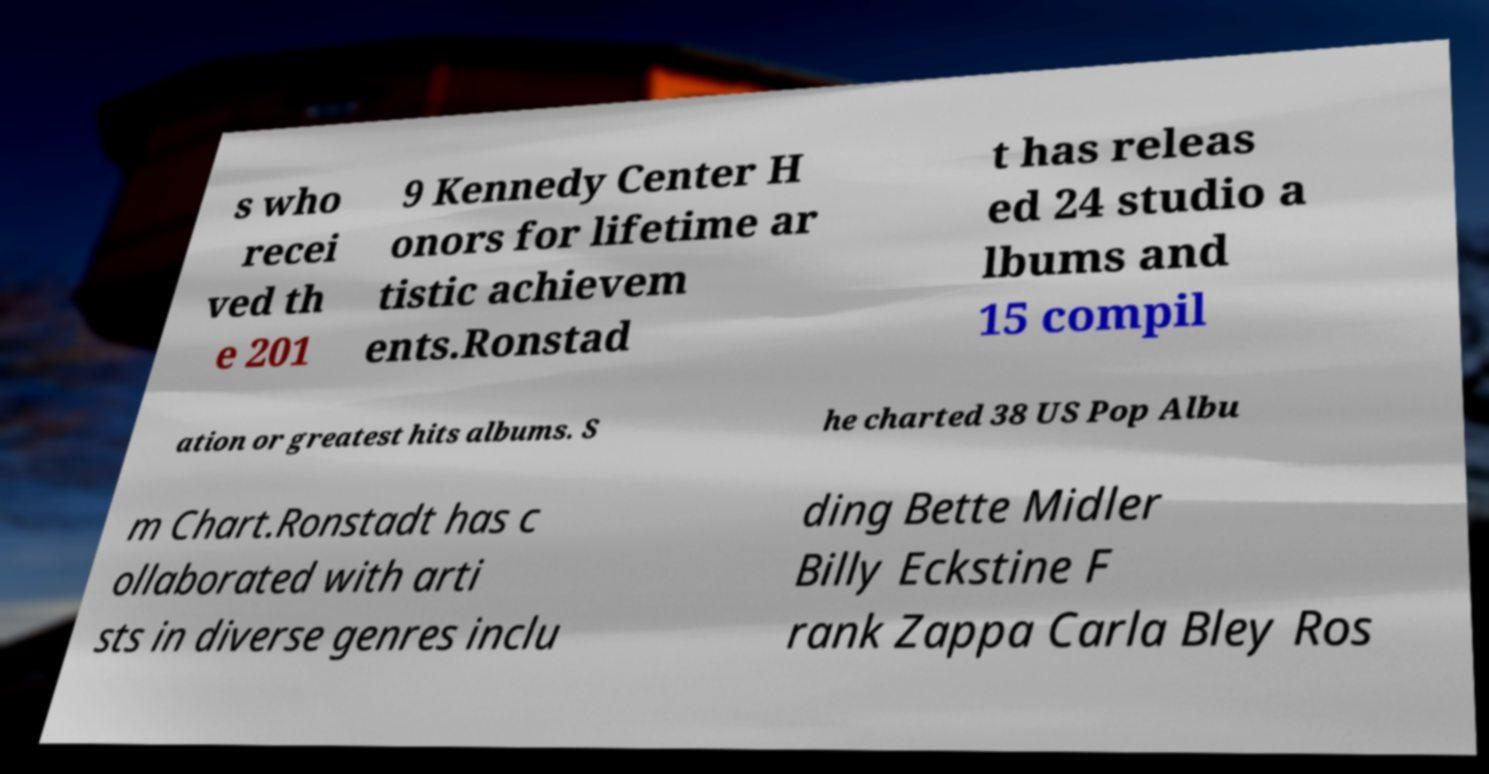Can you accurately transcribe the text from the provided image for me? s who recei ved th e 201 9 Kennedy Center H onors for lifetime ar tistic achievem ents.Ronstad t has releas ed 24 studio a lbums and 15 compil ation or greatest hits albums. S he charted 38 US Pop Albu m Chart.Ronstadt has c ollaborated with arti sts in diverse genres inclu ding Bette Midler Billy Eckstine F rank Zappa Carla Bley Ros 